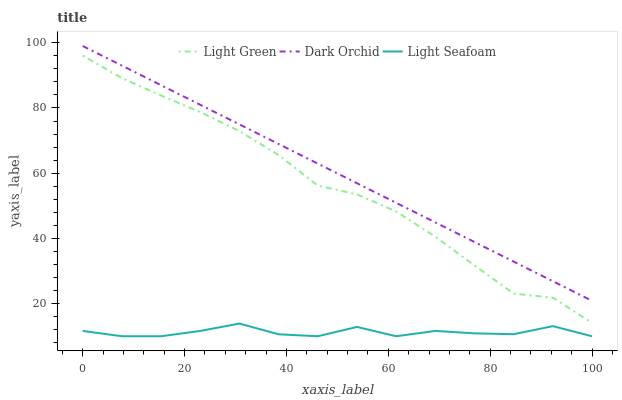Does Light Seafoam have the minimum area under the curve?
Answer yes or no. Yes. Does Dark Orchid have the maximum area under the curve?
Answer yes or no. Yes. Does Light Green have the minimum area under the curve?
Answer yes or no. No. Does Light Green have the maximum area under the curve?
Answer yes or no. No. Is Dark Orchid the smoothest?
Answer yes or no. Yes. Is Light Seafoam the roughest?
Answer yes or no. Yes. Is Light Green the smoothest?
Answer yes or no. No. Is Light Green the roughest?
Answer yes or no. No. Does Light Seafoam have the lowest value?
Answer yes or no. Yes. Does Light Green have the lowest value?
Answer yes or no. No. Does Dark Orchid have the highest value?
Answer yes or no. Yes. Does Light Green have the highest value?
Answer yes or no. No. Is Light Seafoam less than Dark Orchid?
Answer yes or no. Yes. Is Light Green greater than Light Seafoam?
Answer yes or no. Yes. Does Light Seafoam intersect Dark Orchid?
Answer yes or no. No. 